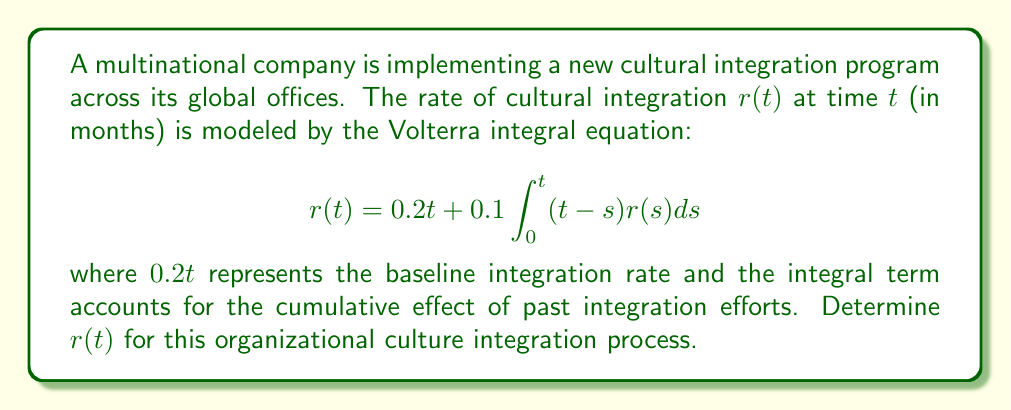Show me your answer to this math problem. To solve this Volterra integral equation, we'll follow these steps:

1) First, we differentiate both sides of the equation with respect to $t$:

   $$\frac{d}{dt}r(t) = 0.2 + 0.1 \int_0^t r(s)ds + 0.1(t-t)r(t) = 0.2 + 0.1 \int_0^t r(s)ds$$

2) Differentiate again:

   $$\frac{d^2}{dt^2}r(t) = 0.1r(t)$$

3) This is a second-order linear differential equation. The general solution is:

   $$r(t) = C_1e^{\frac{\sqrt{10}}{10}t} + C_2e^{-\frac{\sqrt{10}}{10}t}$$

4) To find $C_1$ and $C_2$, we use the initial conditions:
   
   At $t=0$: $r(0) = 0$
   At $t=0$: $r'(0) = 0.2$

5) Applying these conditions:

   $r(0) = C_1 + C_2 = 0$
   $r'(0) = \frac{\sqrt{10}}{10}C_1 - \frac{\sqrt{10}}{10}C_2 = 0.2$

6) Solving these equations:

   $C_1 = \frac{1}{\sqrt{10}}$ and $C_2 = -\frac{1}{\sqrt{10}}$

7) Therefore, the solution is:

   $$r(t) = \frac{1}{\sqrt{10}}(e^{\frac{\sqrt{10}}{10}t} - e^{-\frac{\sqrt{10}}{10}t})$$

This function represents the rate of cultural integration over time in the multinational company.
Answer: $r(t) = \frac{1}{\sqrt{10}}(e^{\frac{\sqrt{10}}{10}t} - e^{-\frac{\sqrt{10}}{10}t})$ 